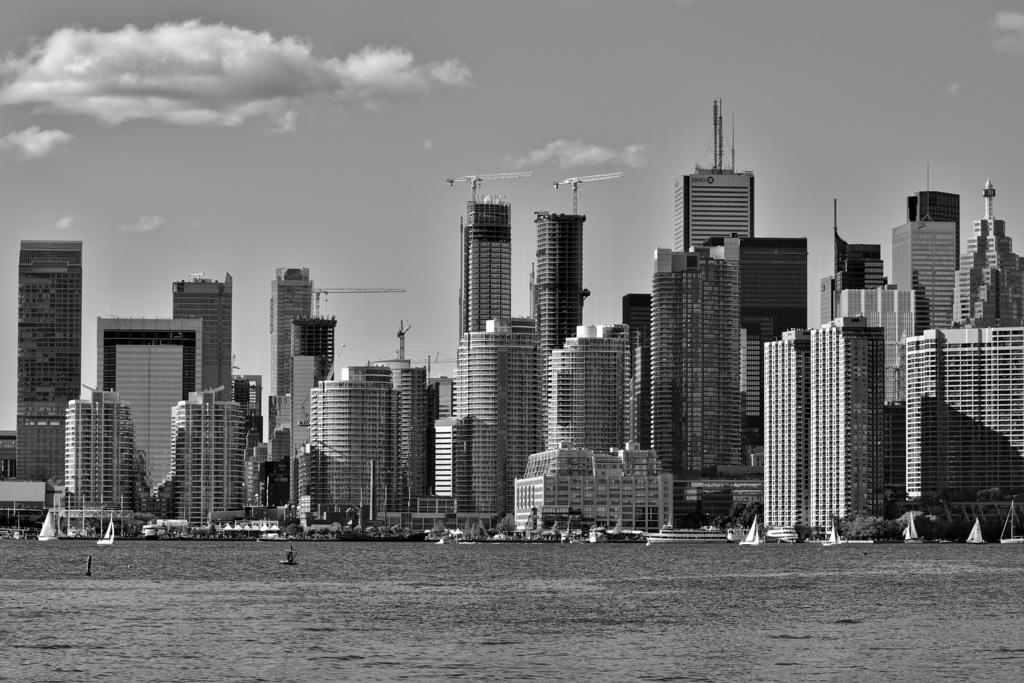What type of structures are visible in the image? There are high rise buildings in the image. What can be seen in front of the buildings? There are boats on a river in front of the buildings. What type of account is being discussed in the image? There is no account being discussed in the image; it features high rise buildings and boats on a river. What selection of items is visible in the image? The image does not depict a selection of items; it shows high rise buildings and boats on a river. 